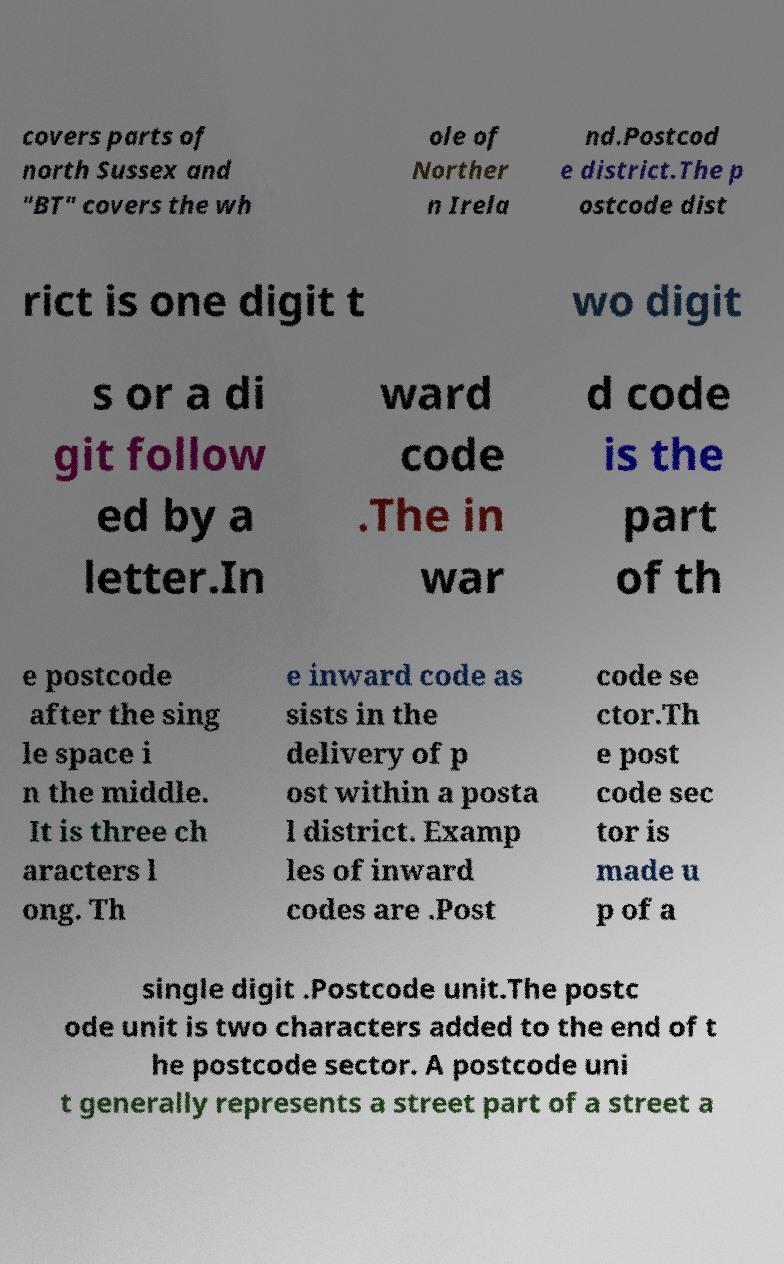What messages or text are displayed in this image? I need them in a readable, typed format. covers parts of north Sussex and "BT" covers the wh ole of Norther n Irela nd.Postcod e district.The p ostcode dist rict is one digit t wo digit s or a di git follow ed by a letter.In ward code .The in war d code is the part of th e postcode after the sing le space i n the middle. It is three ch aracters l ong. Th e inward code as sists in the delivery of p ost within a posta l district. Examp les of inward codes are .Post code se ctor.Th e post code sec tor is made u p of a single digit .Postcode unit.The postc ode unit is two characters added to the end of t he postcode sector. A postcode uni t generally represents a street part of a street a 